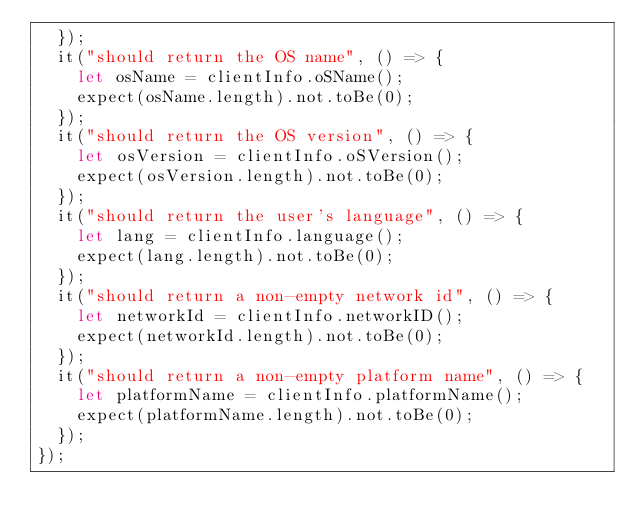<code> <loc_0><loc_0><loc_500><loc_500><_TypeScript_>  });
  it("should return the OS name", () => {
    let osName = clientInfo.oSName();
    expect(osName.length).not.toBe(0);
  });
  it("should return the OS version", () => {
    let osVersion = clientInfo.oSVersion();
    expect(osVersion.length).not.toBe(0);
  });
  it("should return the user's language", () => {
    let lang = clientInfo.language();
    expect(lang.length).not.toBe(0);
  });
  it("should return a non-empty network id", () => {
    let networkId = clientInfo.networkID();
    expect(networkId.length).not.toBe(0);
  });
  it("should return a non-empty platform name", () => {
    let platformName = clientInfo.platformName();
    expect(platformName.length).not.toBe(0);
  });
});
</code> 